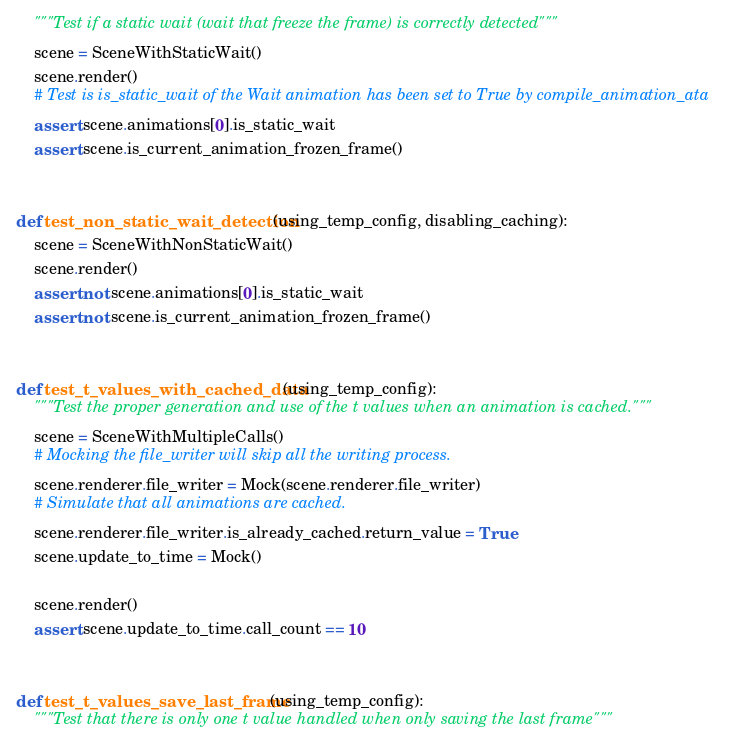Convert code to text. <code><loc_0><loc_0><loc_500><loc_500><_Python_>    """Test if a static wait (wait that freeze the frame) is correctly detected"""
    scene = SceneWithStaticWait()
    scene.render()
    # Test is is_static_wait of the Wait animation has been set to True by compile_animation_ata
    assert scene.animations[0].is_static_wait
    assert scene.is_current_animation_frozen_frame()


def test_non_static_wait_detection(using_temp_config, disabling_caching):
    scene = SceneWithNonStaticWait()
    scene.render()
    assert not scene.animations[0].is_static_wait
    assert not scene.is_current_animation_frozen_frame()


def test_t_values_with_cached_data(using_temp_config):
    """Test the proper generation and use of the t values when an animation is cached."""
    scene = SceneWithMultipleCalls()
    # Mocking the file_writer will skip all the writing process.
    scene.renderer.file_writer = Mock(scene.renderer.file_writer)
    # Simulate that all animations are cached.
    scene.renderer.file_writer.is_already_cached.return_value = True
    scene.update_to_time = Mock()

    scene.render()
    assert scene.update_to_time.call_count == 10


def test_t_values_save_last_frame(using_temp_config):
    """Test that there is only one t value handled when only saving the last frame"""</code> 